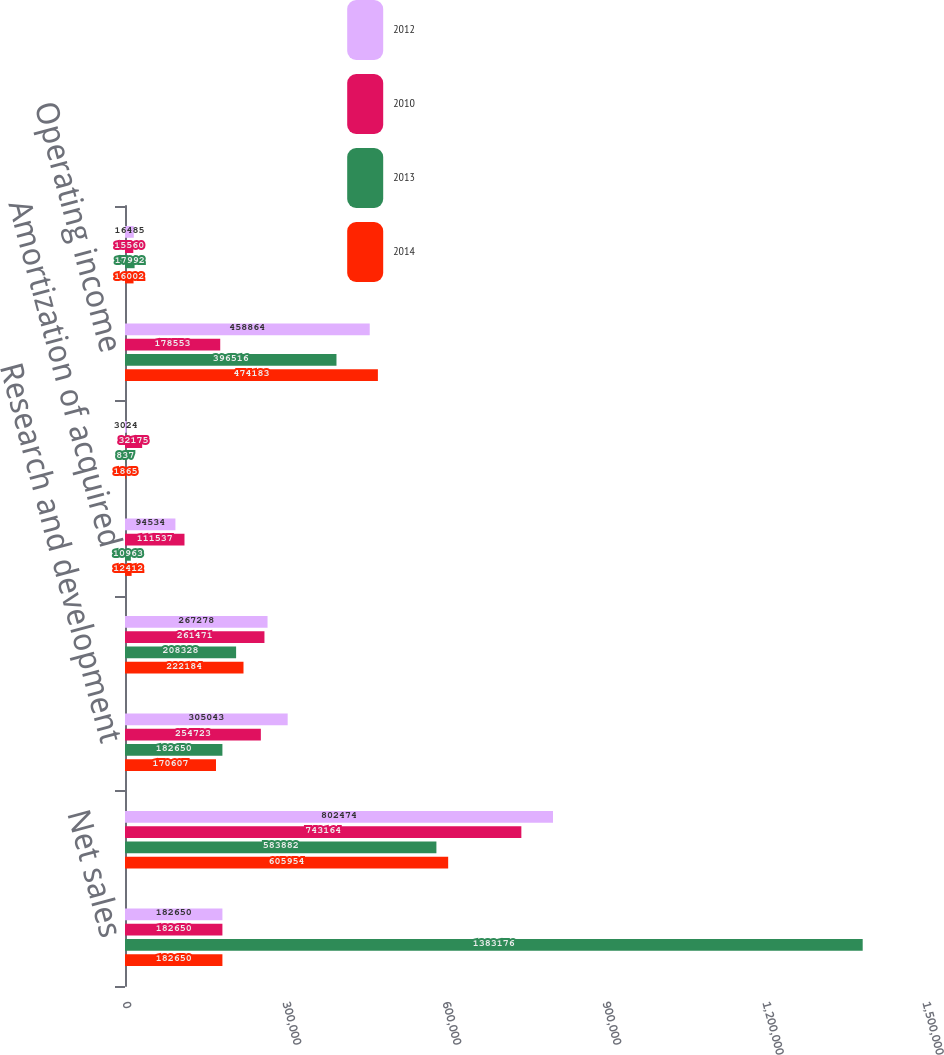Convert chart to OTSL. <chart><loc_0><loc_0><loc_500><loc_500><stacked_bar_chart><ecel><fcel>Net sales<fcel>Cost of sales<fcel>Research and development<fcel>Selling general and<fcel>Amortization of acquired<fcel>Special charges net (1)<fcel>Operating income<fcel>Interest income<nl><fcel>2012<fcel>182650<fcel>802474<fcel>305043<fcel>267278<fcel>94534<fcel>3024<fcel>458864<fcel>16485<nl><fcel>2010<fcel>182650<fcel>743164<fcel>254723<fcel>261471<fcel>111537<fcel>32175<fcel>178553<fcel>15560<nl><fcel>2013<fcel>1.38318e+06<fcel>583882<fcel>182650<fcel>208328<fcel>10963<fcel>837<fcel>396516<fcel>17992<nl><fcel>2014<fcel>182650<fcel>605954<fcel>170607<fcel>222184<fcel>12412<fcel>1865<fcel>474183<fcel>16002<nl></chart> 